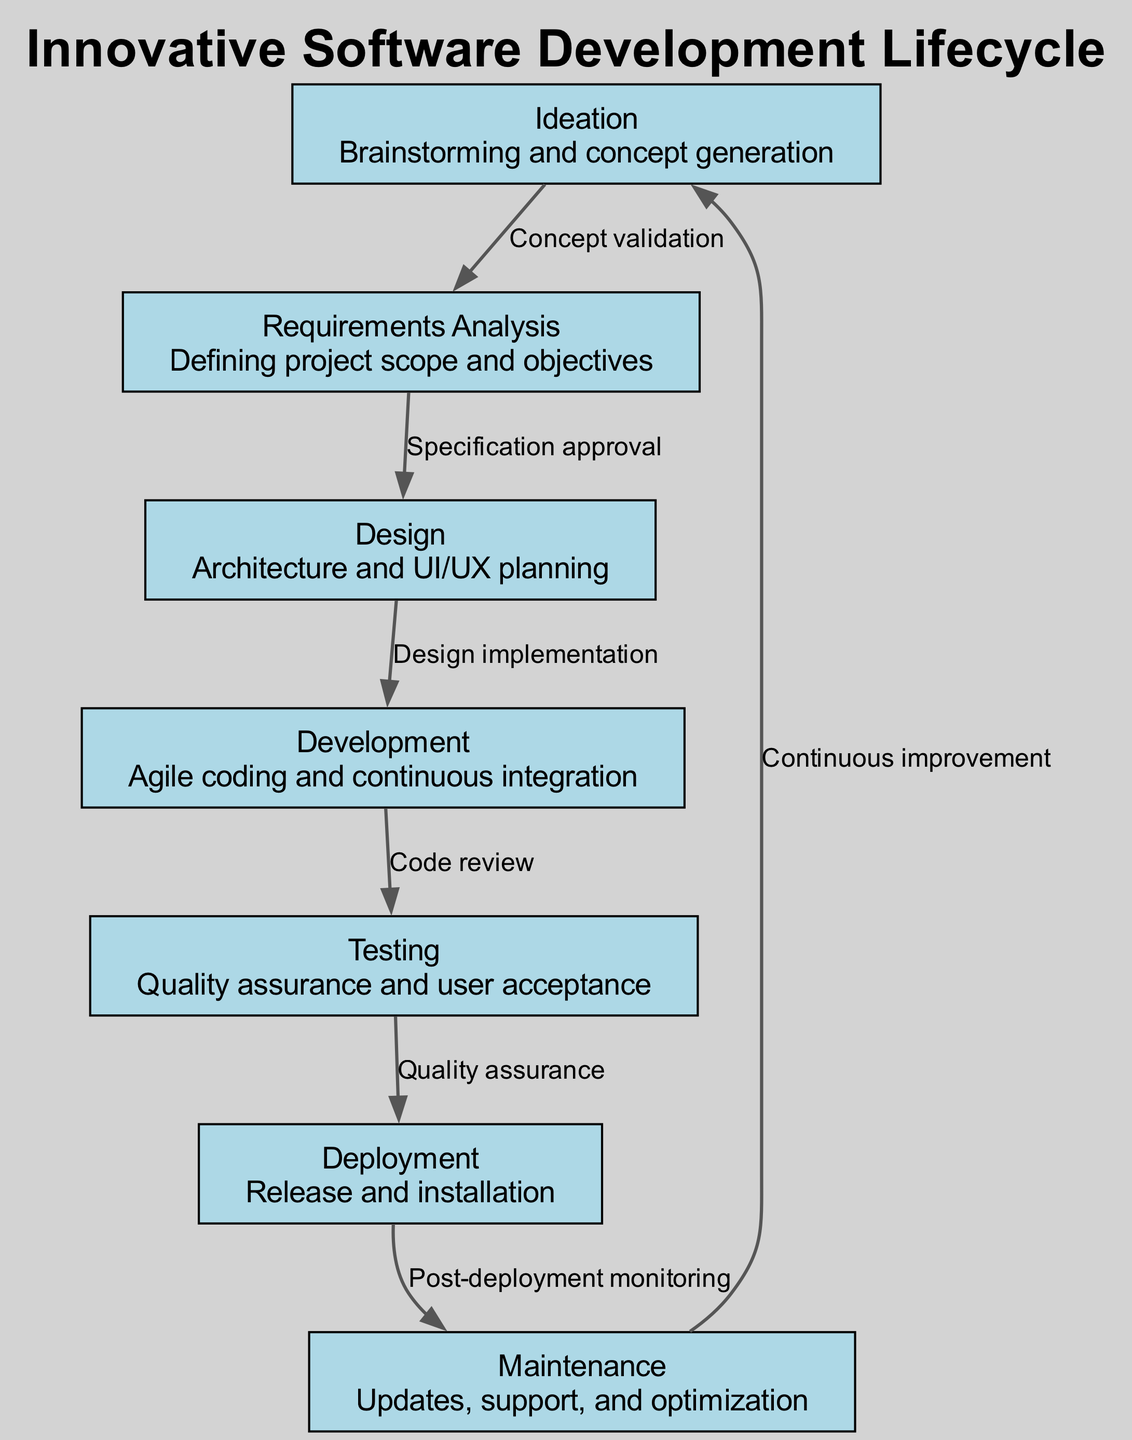What is the first phase of the software development lifecycle? The first phase listed in the diagram is "Ideation," which focuses on brainstorming and concept generation.
Answer: Ideation How many phases are there in this software development lifecycle? The diagram contains a total of seven phases, as indicated by the seven nodes present in the diagram.
Answer: Seven What is the connection between Requirements Analysis and Design? The connection indicates that "Specification approval" is necessary to move from Requirements Analysis to Design, showing a dependency in the phases.
Answer: Specification approval What follows the Testing phase in the lifecycle? The phase that follows Testing, as shown in the diagram, is Deployment, which is the process of release and installation.
Answer: Deployment Which phase includes continuous improvement? The phase that incorporates continuous improvement is Maintenance, which also involves updates, support, and optimization of the software.
Answer: Maintenance What type of activity is emphasized in the Development phase? The Development phase emphasizes "Agile coding and continuous integration," highlighting a methodology that promotes flexibility and ongoing updates.
Answer: Agile coding and continuous integration How do the phases connect back to Ideation? The diagram shows that after Maintenance, there is a connection back to Ideation labeled "Continuous improvement," indicating a cyclical process that incorporates feedback for future enhancements.
Answer: Continuous improvement What is the nature of the relationship from Design to Development? The relationship from Design to Development is characterized by "Design implementation," demonstrating that the actual coding processes are based on the design specifications.
Answer: Design implementation What does the edge from Deployment to Maintenance indicate? The edge from Deployment to Maintenance indicates "Post-deployment monitoring," which suggests an ongoing observation of the system after it has been deployed for effective maintenance.
Answer: Post-deployment monitoring 